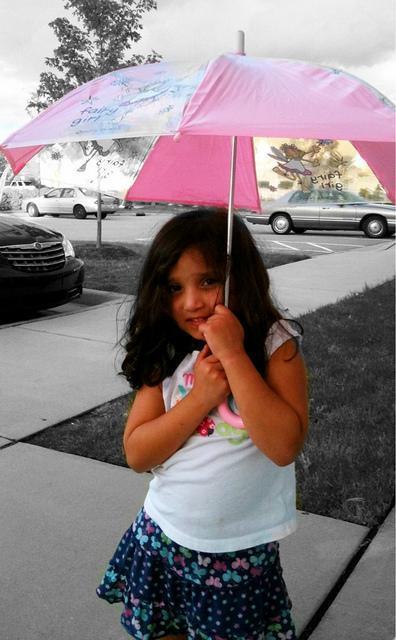Does the image validate the caption "The umbrella is over the person."?
Answer yes or no. Yes. 